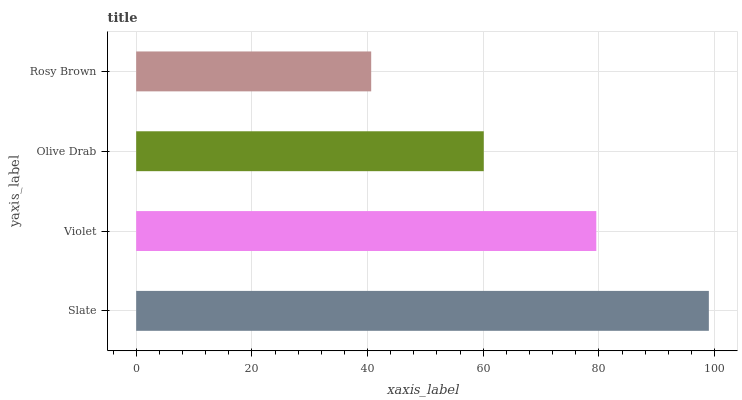Is Rosy Brown the minimum?
Answer yes or no. Yes. Is Slate the maximum?
Answer yes or no. Yes. Is Violet the minimum?
Answer yes or no. No. Is Violet the maximum?
Answer yes or no. No. Is Slate greater than Violet?
Answer yes or no. Yes. Is Violet less than Slate?
Answer yes or no. Yes. Is Violet greater than Slate?
Answer yes or no. No. Is Slate less than Violet?
Answer yes or no. No. Is Violet the high median?
Answer yes or no. Yes. Is Olive Drab the low median?
Answer yes or no. Yes. Is Rosy Brown the high median?
Answer yes or no. No. Is Slate the low median?
Answer yes or no. No. 